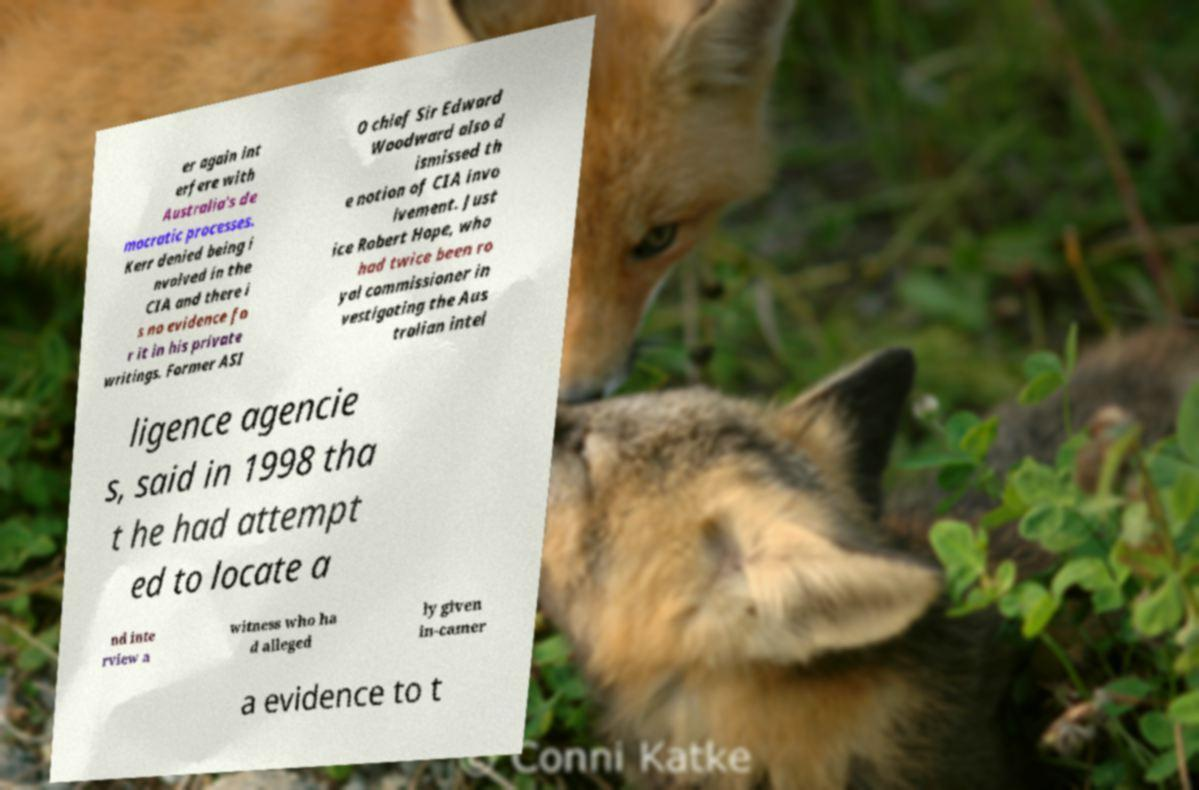What messages or text are displayed in this image? I need them in a readable, typed format. er again int erfere with Australia's de mocratic processes. Kerr denied being i nvolved in the CIA and there i s no evidence fo r it in his private writings. Former ASI O chief Sir Edward Woodward also d ismissed th e notion of CIA invo lvement. Just ice Robert Hope, who had twice been ro yal commissioner in vestigating the Aus tralian intel ligence agencie s, said in 1998 tha t he had attempt ed to locate a nd inte rview a witness who ha d alleged ly given in-camer a evidence to t 